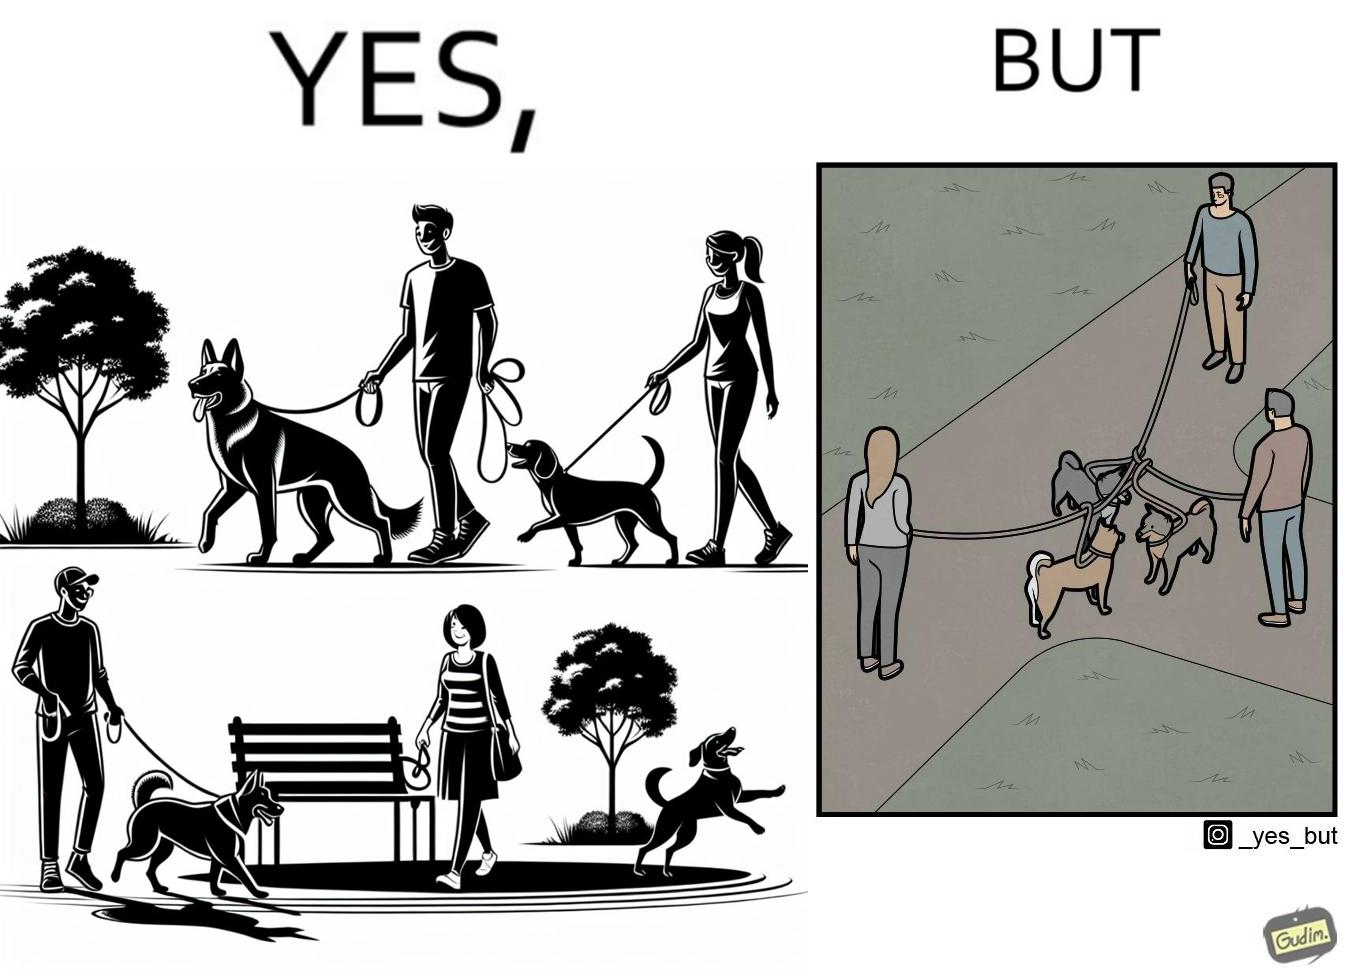Describe the content of this image. The dog owners take their dogs for some walk in parks but their dogs mingle together with other dogs however their leashes get entangled during this which is quite inconvenient for the dog owners 